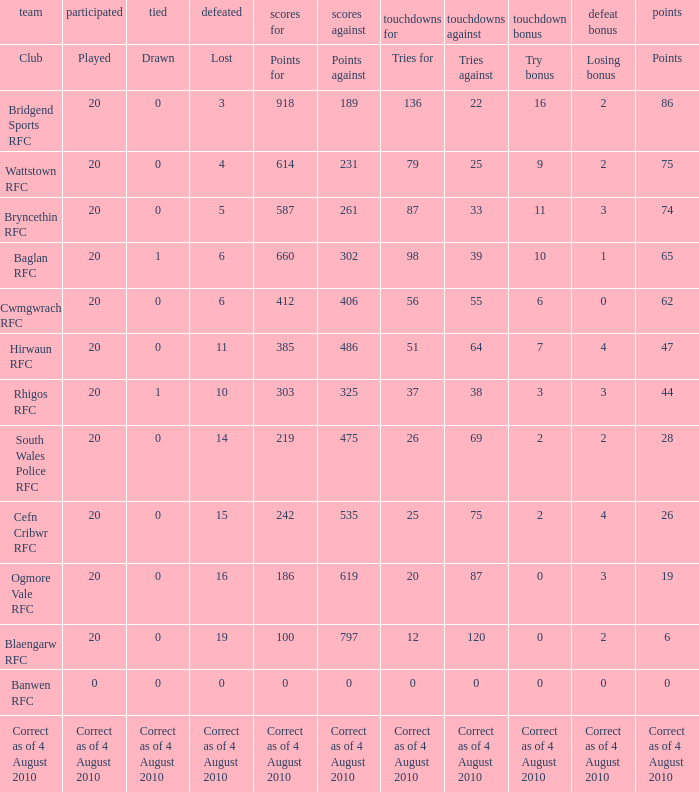In the context of tries fow, what is the consequence of losing the bonus when the bonus is lost? Tries for. 